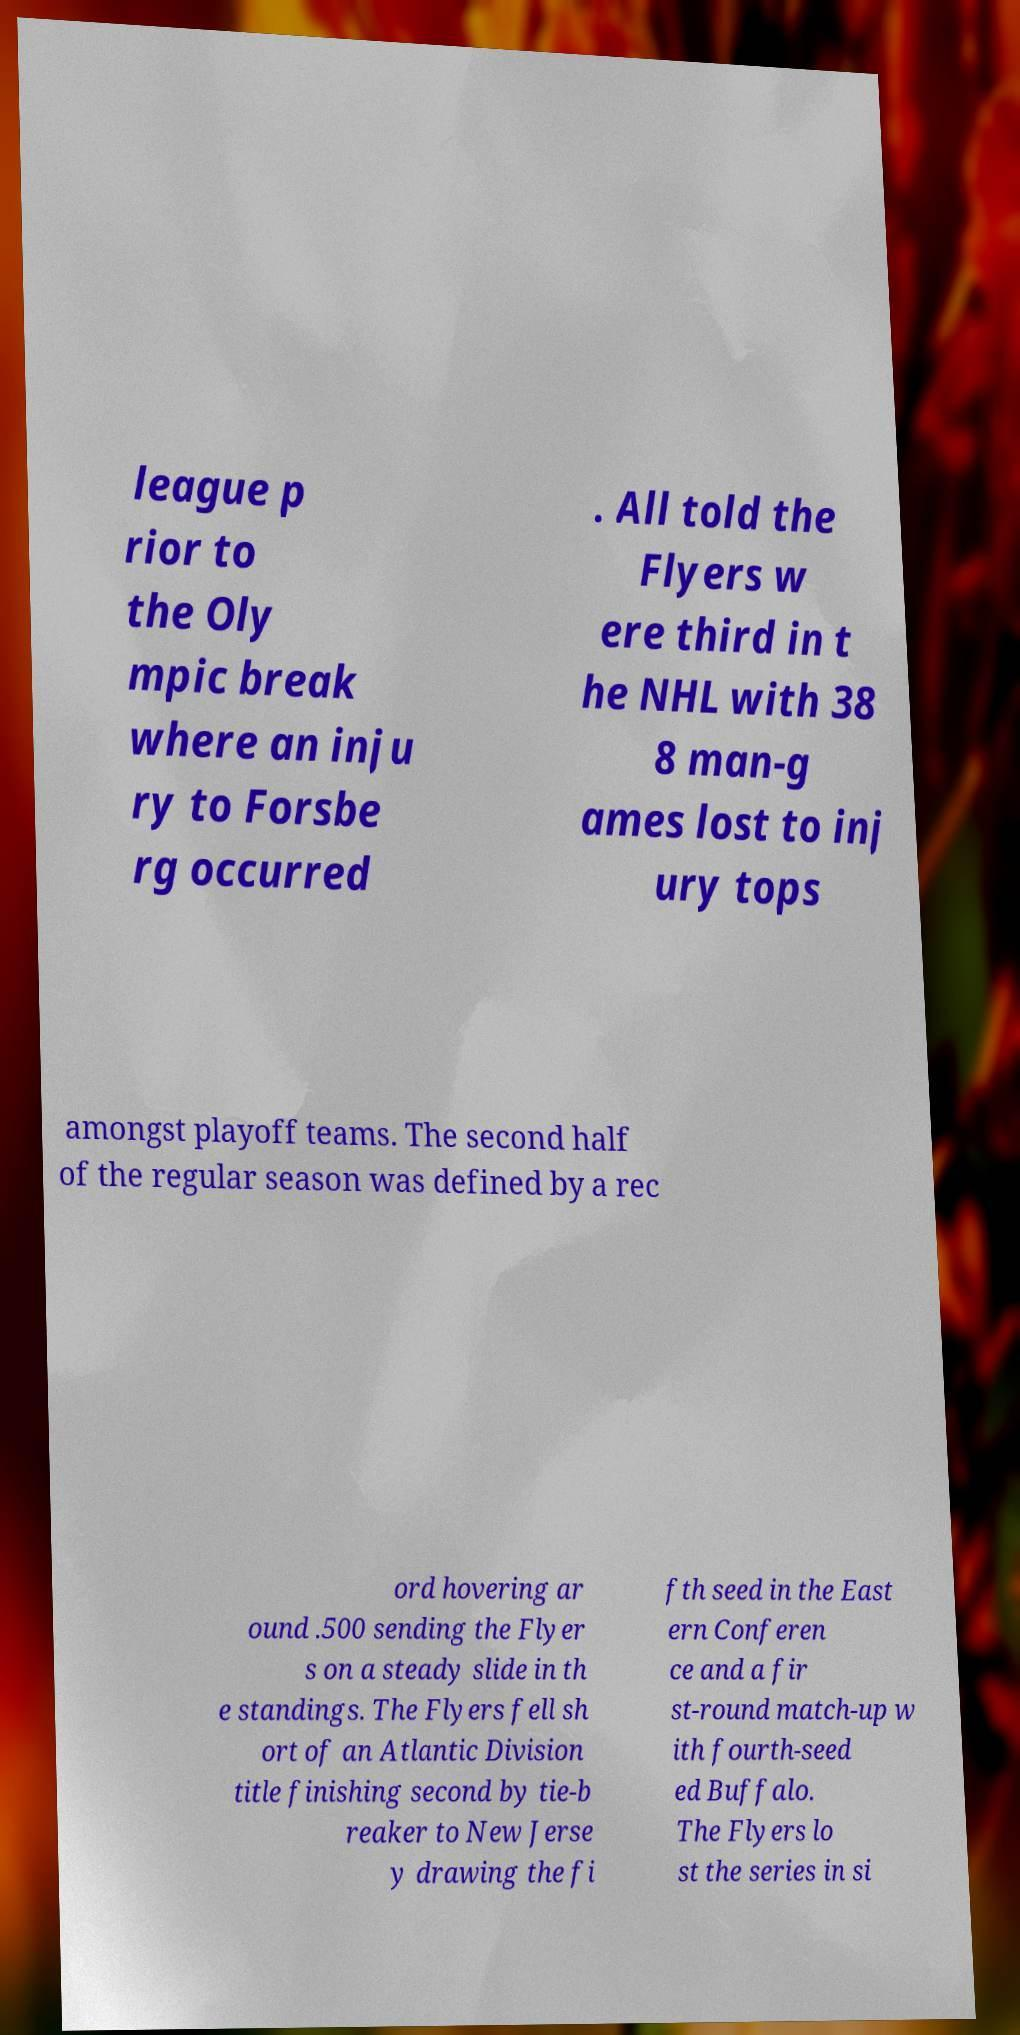Please identify and transcribe the text found in this image. league p rior to the Oly mpic break where an inju ry to Forsbe rg occurred . All told the Flyers w ere third in t he NHL with 38 8 man-g ames lost to inj ury tops amongst playoff teams. The second half of the regular season was defined by a rec ord hovering ar ound .500 sending the Flyer s on a steady slide in th e standings. The Flyers fell sh ort of an Atlantic Division title finishing second by tie-b reaker to New Jerse y drawing the fi fth seed in the East ern Conferen ce and a fir st-round match-up w ith fourth-seed ed Buffalo. The Flyers lo st the series in si 